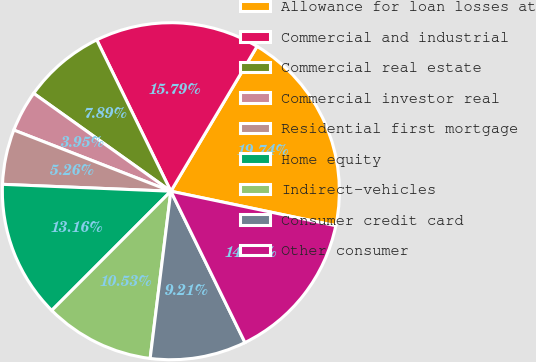<chart> <loc_0><loc_0><loc_500><loc_500><pie_chart><fcel>Allowance for loan losses at<fcel>Commercial and industrial<fcel>Commercial real estate<fcel>Commercial investor real<fcel>Residential first mortgage<fcel>Home equity<fcel>Indirect-vehicles<fcel>Consumer credit card<fcel>Other consumer<nl><fcel>19.74%<fcel>15.79%<fcel>7.89%<fcel>3.95%<fcel>5.26%<fcel>13.16%<fcel>10.53%<fcel>9.21%<fcel>14.47%<nl></chart> 